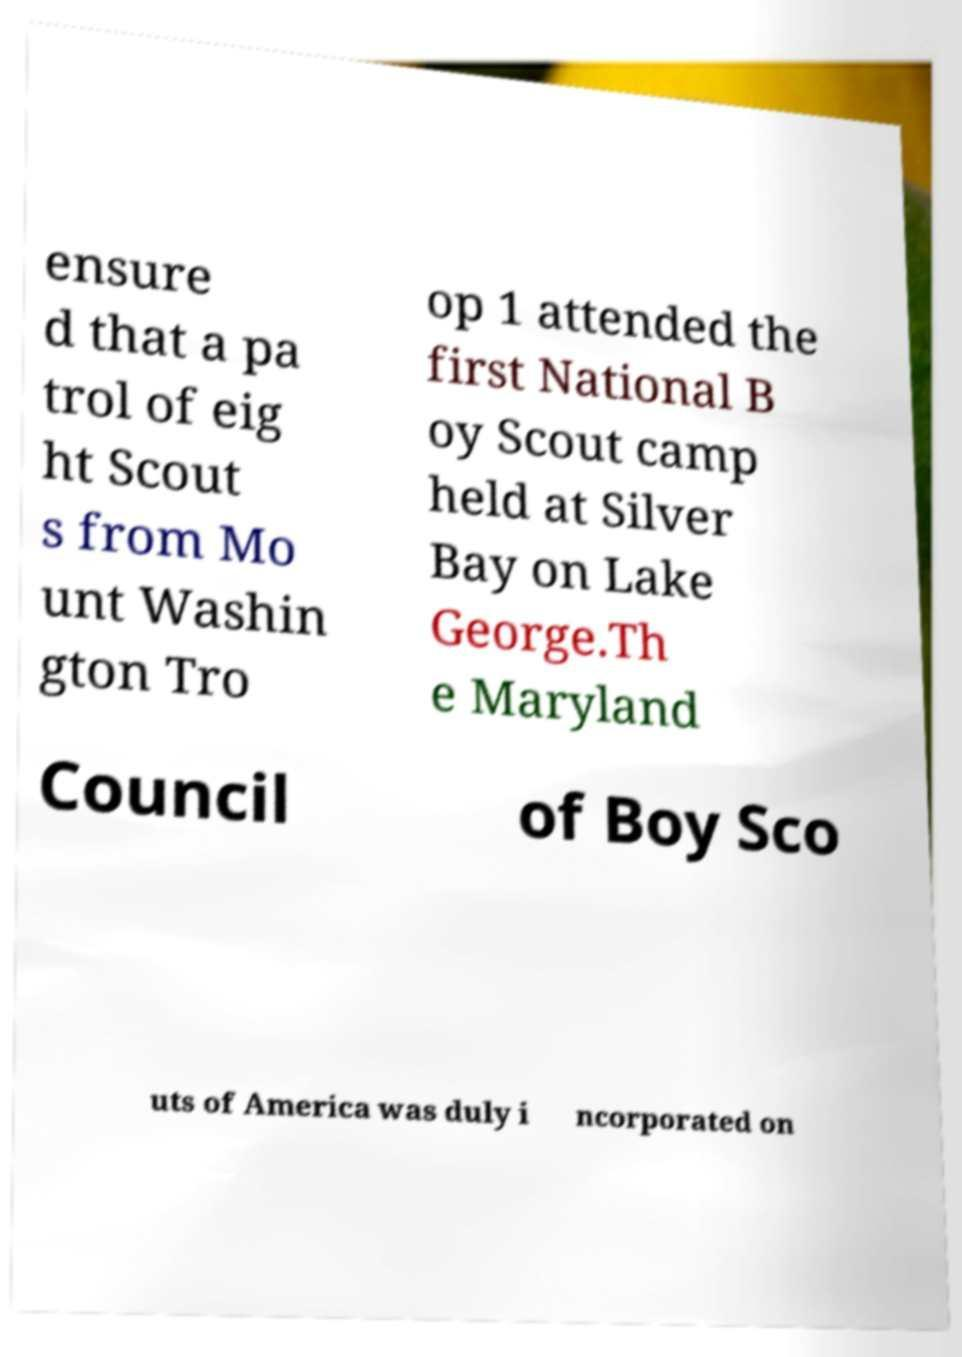Please identify and transcribe the text found in this image. ensure d that a pa trol of eig ht Scout s from Mo unt Washin gton Tro op 1 attended the first National B oy Scout camp held at Silver Bay on Lake George.Th e Maryland Council of Boy Sco uts of America was duly i ncorporated on 